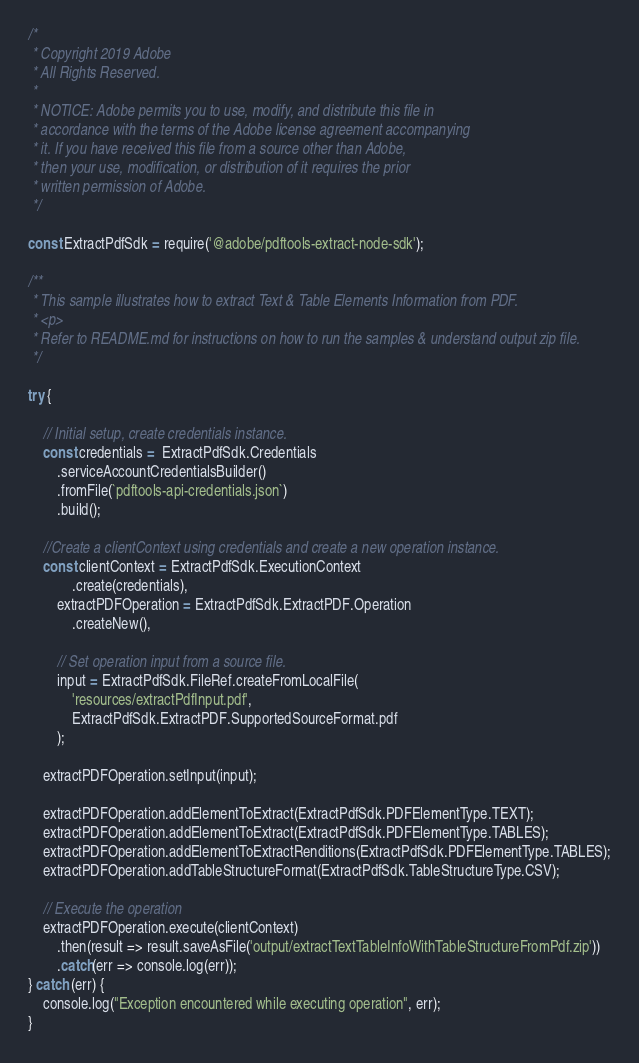Convert code to text. <code><loc_0><loc_0><loc_500><loc_500><_JavaScript_>/*
 * Copyright 2019 Adobe
 * All Rights Reserved.
 *
 * NOTICE: Adobe permits you to use, modify, and distribute this file in
 * accordance with the terms of the Adobe license agreement accompanying
 * it. If you have received this file from a source other than Adobe,
 * then your use, modification, or distribution of it requires the prior
 * written permission of Adobe.
 */

const ExtractPdfSdk = require('@adobe/pdftools-extract-node-sdk');

/**
 * This sample illustrates how to extract Text & Table Elements Information from PDF.
 * <p>
 * Refer to README.md for instructions on how to run the samples & understand output zip file.
 */

try {

    // Initial setup, create credentials instance.
    const credentials =  ExtractPdfSdk.Credentials
        .serviceAccountCredentialsBuilder()
        .fromFile(`pdftools-api-credentials.json`)
        .build();

    //Create a clientContext using credentials and create a new operation instance.
    const clientContext = ExtractPdfSdk.ExecutionContext
            .create(credentials),
        extractPDFOperation = ExtractPdfSdk.ExtractPDF.Operation
            .createNew(),

        // Set operation input from a source file.
        input = ExtractPdfSdk.FileRef.createFromLocalFile(
            'resources/extractPdfInput.pdf',
            ExtractPdfSdk.ExtractPDF.SupportedSourceFormat.pdf
        );

    extractPDFOperation.setInput(input);

    extractPDFOperation.addElementToExtract(ExtractPdfSdk.PDFElementType.TEXT);
    extractPDFOperation.addElementToExtract(ExtractPdfSdk.PDFElementType.TABLES);
    extractPDFOperation.addElementToExtractRenditions(ExtractPdfSdk.PDFElementType.TABLES);
    extractPDFOperation.addTableStructureFormat(ExtractPdfSdk.TableStructureType.CSV);

    // Execute the operation
    extractPDFOperation.execute(clientContext)
        .then(result => result.saveAsFile('output/extractTextTableInfoWithTableStructureFromPdf.zip'))
        .catch(err => console.log(err));
} catch (err) {
    console.log("Exception encountered while executing operation", err);
}
</code> 